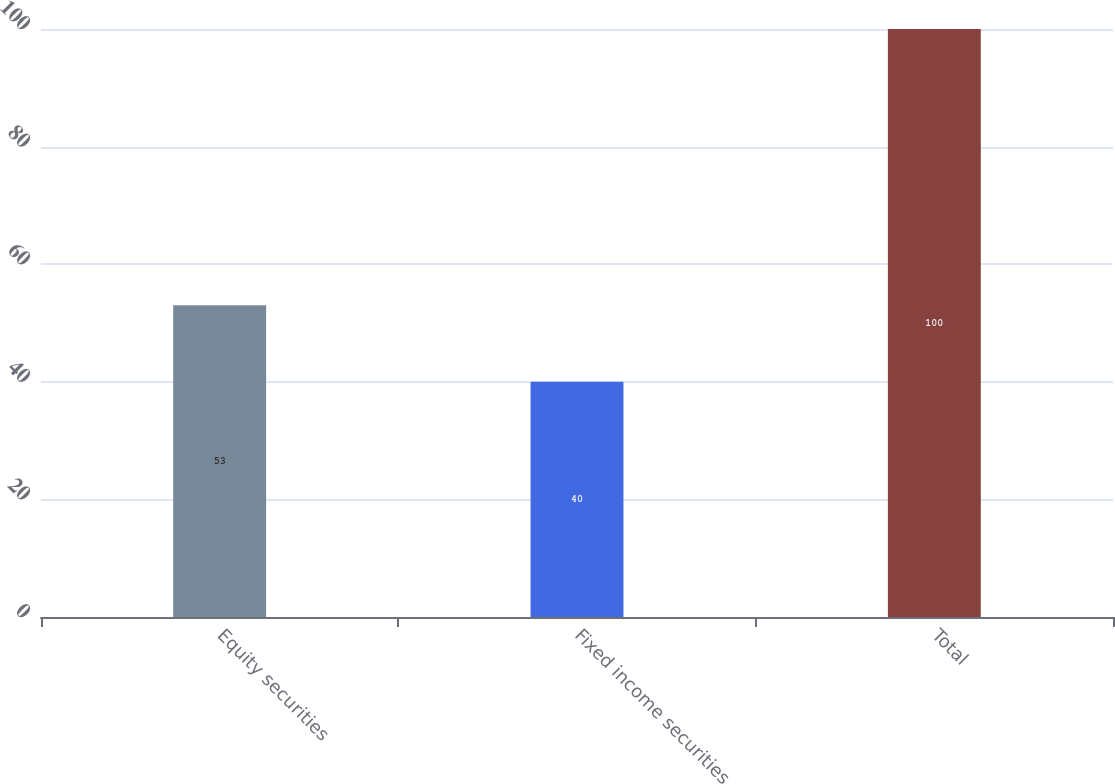Convert chart. <chart><loc_0><loc_0><loc_500><loc_500><bar_chart><fcel>Equity securities<fcel>Fixed income securities<fcel>Total<nl><fcel>53<fcel>40<fcel>100<nl></chart> 